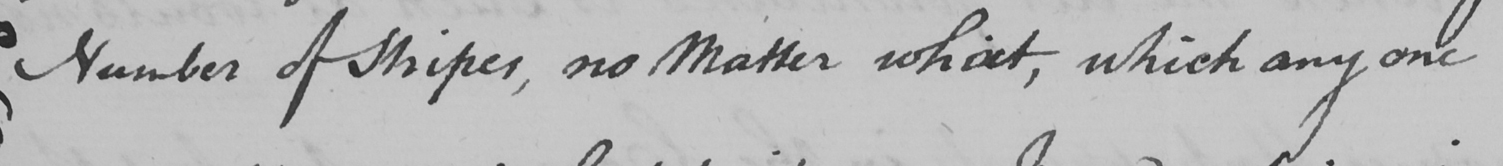What does this handwritten line say? Number of Stripes , no Matter what , which any one 